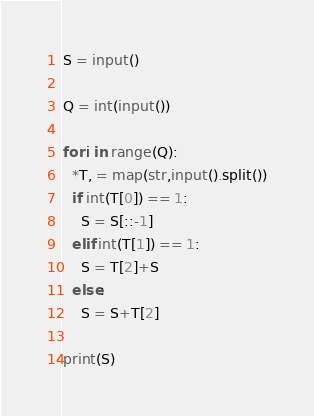Convert code to text. <code><loc_0><loc_0><loc_500><loc_500><_Python_>S = input()

Q = int(input())

for i in range(Q):
  *T, = map(str,input().split())
  if int(T[0]) == 1:
    S = S[::-1]
  elif int(T[1]) == 1:
    S = T[2]+S
  else:
    S = S+T[2]
    
print(S) </code> 